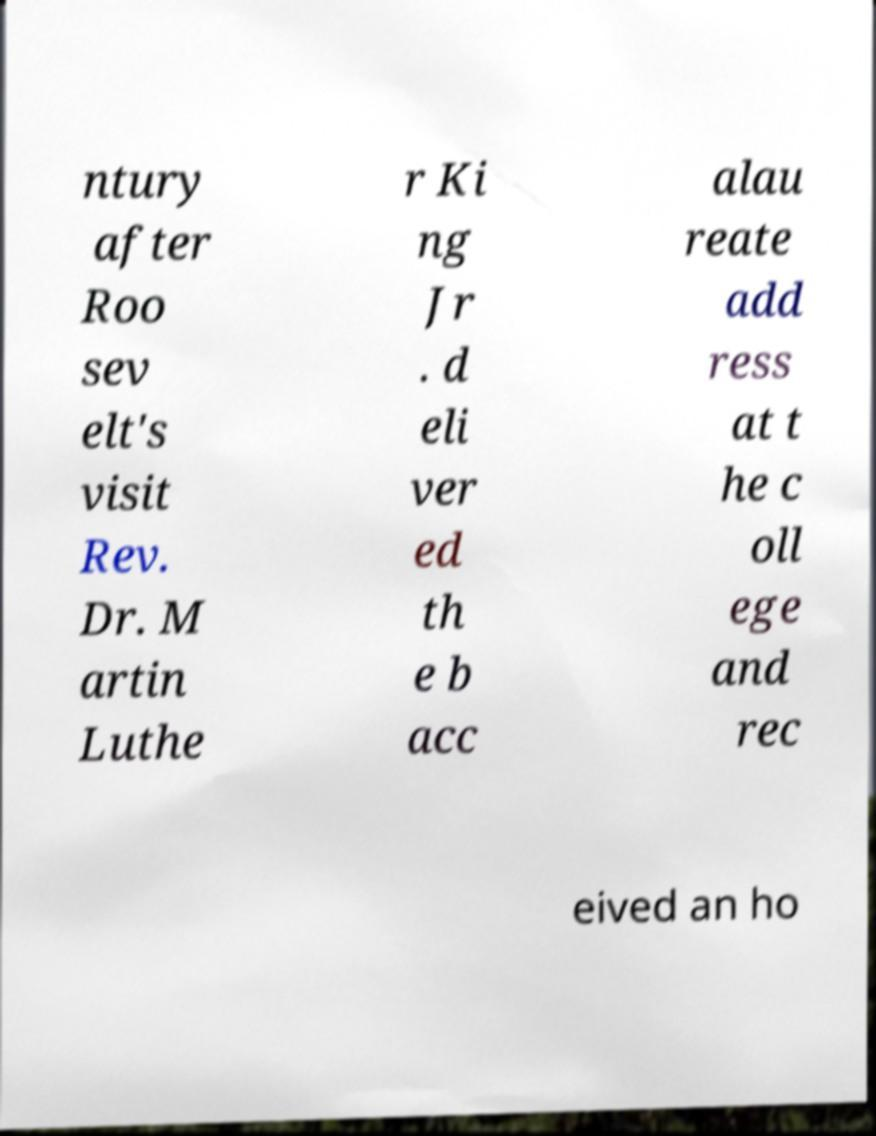There's text embedded in this image that I need extracted. Can you transcribe it verbatim? ntury after Roo sev elt's visit Rev. Dr. M artin Luthe r Ki ng Jr . d eli ver ed th e b acc alau reate add ress at t he c oll ege and rec eived an ho 